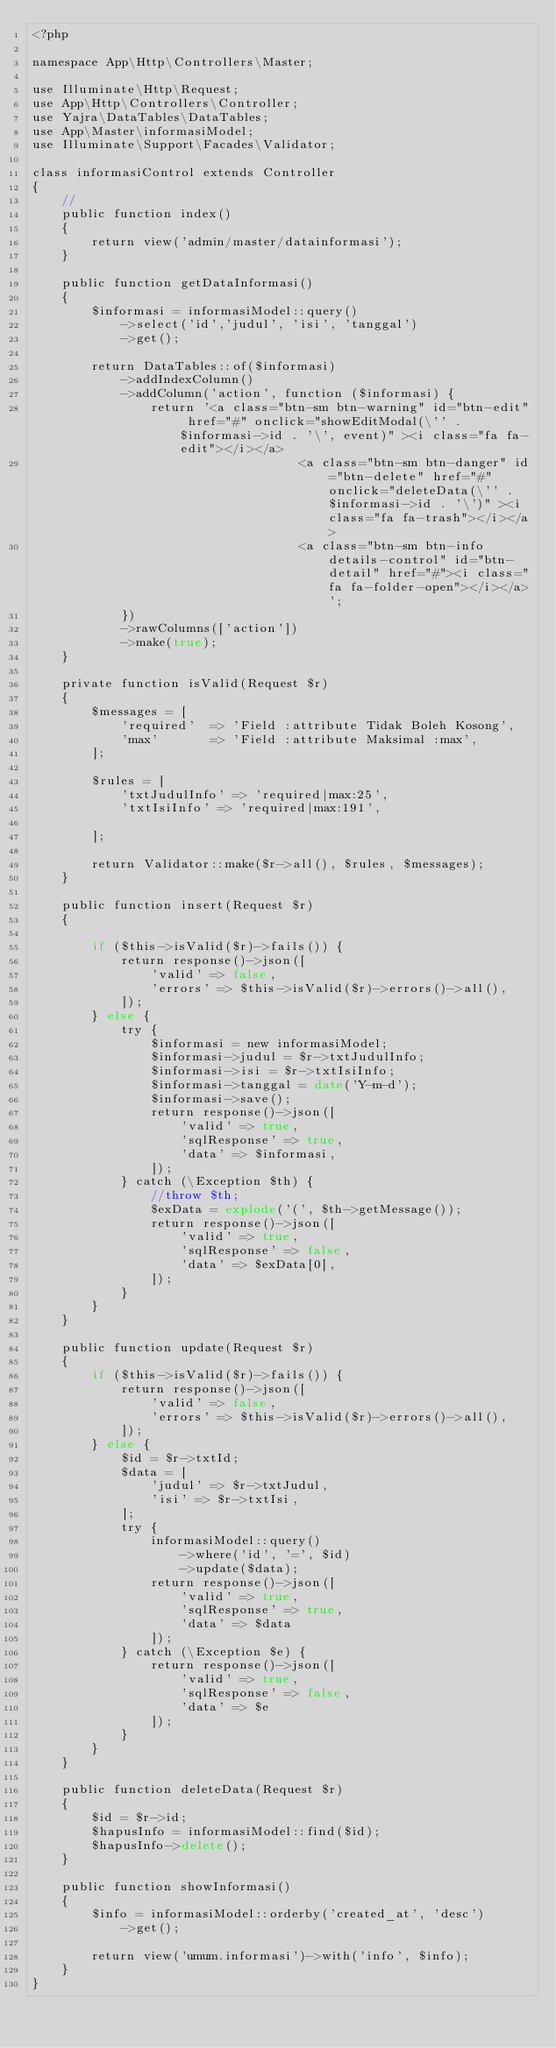<code> <loc_0><loc_0><loc_500><loc_500><_PHP_><?php

namespace App\Http\Controllers\Master;

use Illuminate\Http\Request;
use App\Http\Controllers\Controller;
use Yajra\DataTables\DataTables;
use App\Master\informasiModel;
use Illuminate\Support\Facades\Validator;

class informasiControl extends Controller
{
    //
    public function index()
    {
        return view('admin/master/datainformasi');
    }

    public function getDataInformasi()
    {
        $informasi = informasiModel::query()
            ->select('id','judul', 'isi', 'tanggal')
            ->get();

        return DataTables::of($informasi)
            ->addIndexColumn()
            ->addColumn('action', function ($informasi) {
                return '<a class="btn-sm btn-warning" id="btn-edit" href="#" onclick="showEditModal(\'' . $informasi->id . '\', event)" ><i class="fa fa-edit"></i></a>
                                    <a class="btn-sm btn-danger" id="btn-delete" href="#" onclick="deleteData(\'' . $informasi->id . '\')" ><i class="fa fa-trash"></i></a>
                                    <a class="btn-sm btn-info details-control" id="btn-detail" href="#"><i class="fa fa-folder-open"></i></a>';
            })
            ->rawColumns(['action'])
            ->make(true);
    }

    private function isValid(Request $r)
    {
        $messages = [
            'required'  => 'Field :attribute Tidak Boleh Kosong',
            'max'       => 'Field :attribute Maksimal :max',
        ];

        $rules = [
            'txtJudulInfo' => 'required|max:25',
            'txtIsiInfo' => 'required|max:191',

        ];

        return Validator::make($r->all(), $rules, $messages);
    }

    public function insert(Request $r)
    {

        if ($this->isValid($r)->fails()) {
            return response()->json([
                'valid' => false,
                'errors' => $this->isValid($r)->errors()->all(),
            ]);
        } else {
            try {
                $informasi = new informasiModel;
                $informasi->judul = $r->txtJudulInfo;
                $informasi->isi = $r->txtIsiInfo;
                $informasi->tanggal = date('Y-m-d');
                $informasi->save();
                return response()->json([
                    'valid' => true,
                    'sqlResponse' => true,
                    'data' => $informasi,
                ]);
            } catch (\Exception $th) {
                //throw $th;
                $exData = explode('(', $th->getMessage());
                return response()->json([
                    'valid' => true,
                    'sqlResponse' => false,
                    'data' => $exData[0],
                ]);
            }
        }
    }

    public function update(Request $r)
    {
        if ($this->isValid($r)->fails()) {
            return response()->json([
                'valid' => false,
                'errors' => $this->isValid($r)->errors()->all(),
            ]);
        } else {
            $id = $r->txtId;
            $data = [
                'judul' => $r->txtJudul,
                'isi' => $r->txtIsi,
            ];
            try {
                informasiModel::query()
                    ->where('id', '=', $id)
                    ->update($data);
                return response()->json([
                    'valid' => true,
                    'sqlResponse' => true,
                    'data' => $data
                ]);
            } catch (\Exception $e) {
                return response()->json([
                    'valid' => true,
                    'sqlResponse' => false,
                    'data' => $e
                ]);
            }
        }
    }

    public function deleteData(Request $r)
    {
        $id = $r->id;
        $hapusInfo = informasiModel::find($id);
        $hapusInfo->delete();
    }

    public function showInformasi()
    {
        $info = informasiModel::orderby('created_at', 'desc')
            ->get();

        return view('umum.informasi')->with('info', $info);
    }
}
</code> 